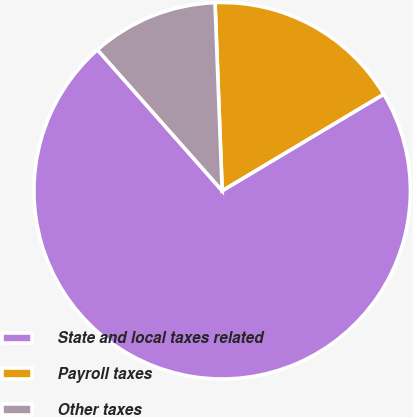<chart> <loc_0><loc_0><loc_500><loc_500><pie_chart><fcel>State and local taxes related<fcel>Payroll taxes<fcel>Other taxes<nl><fcel>72.05%<fcel>17.03%<fcel>10.92%<nl></chart> 